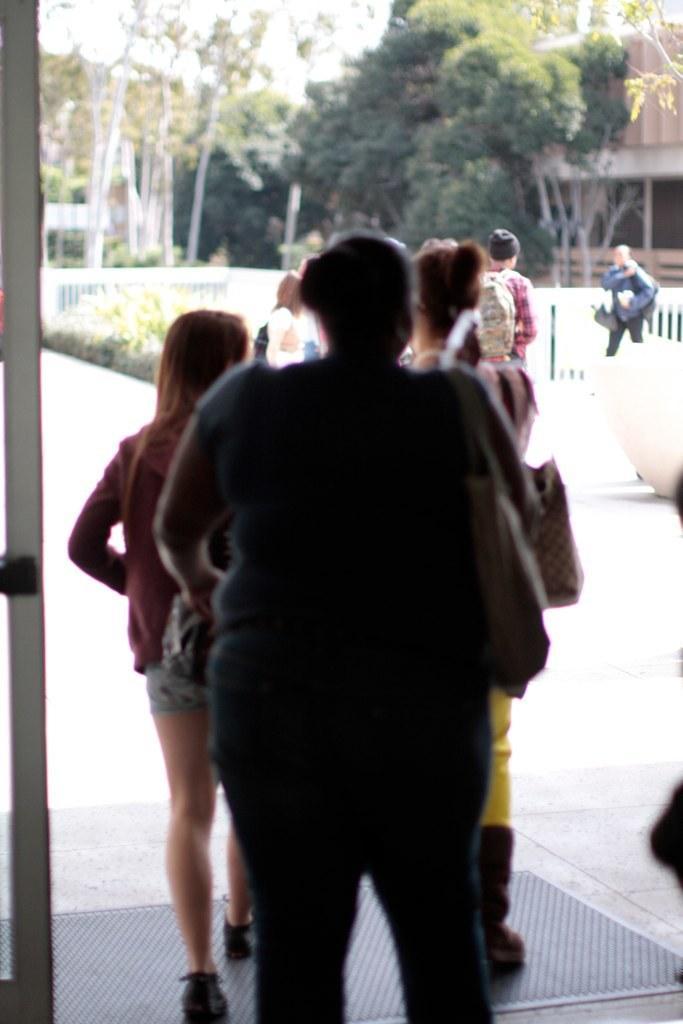Describe this image in one or two sentences. In this image, we can see a group of people. Few are standing and walking. Background we can see so many trees, houses, plants, railings. 